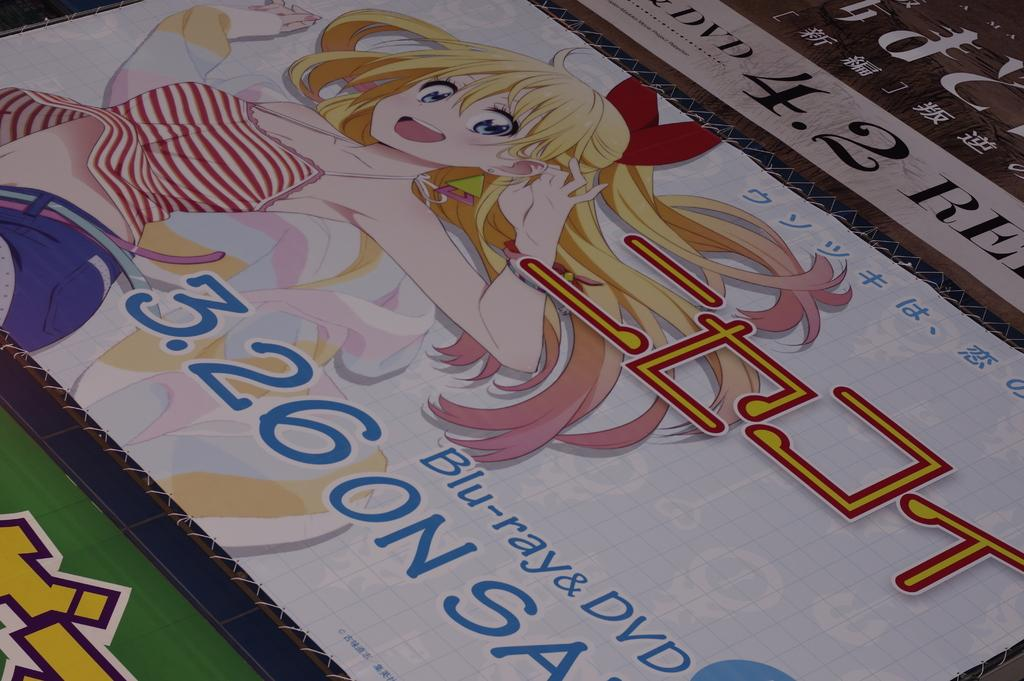What is the main object in the image? There is a banner in the image. Can you see any islands in the background of the image? There is no reference to an island or any background in the provided fact, so it is not possible to answer that question. 